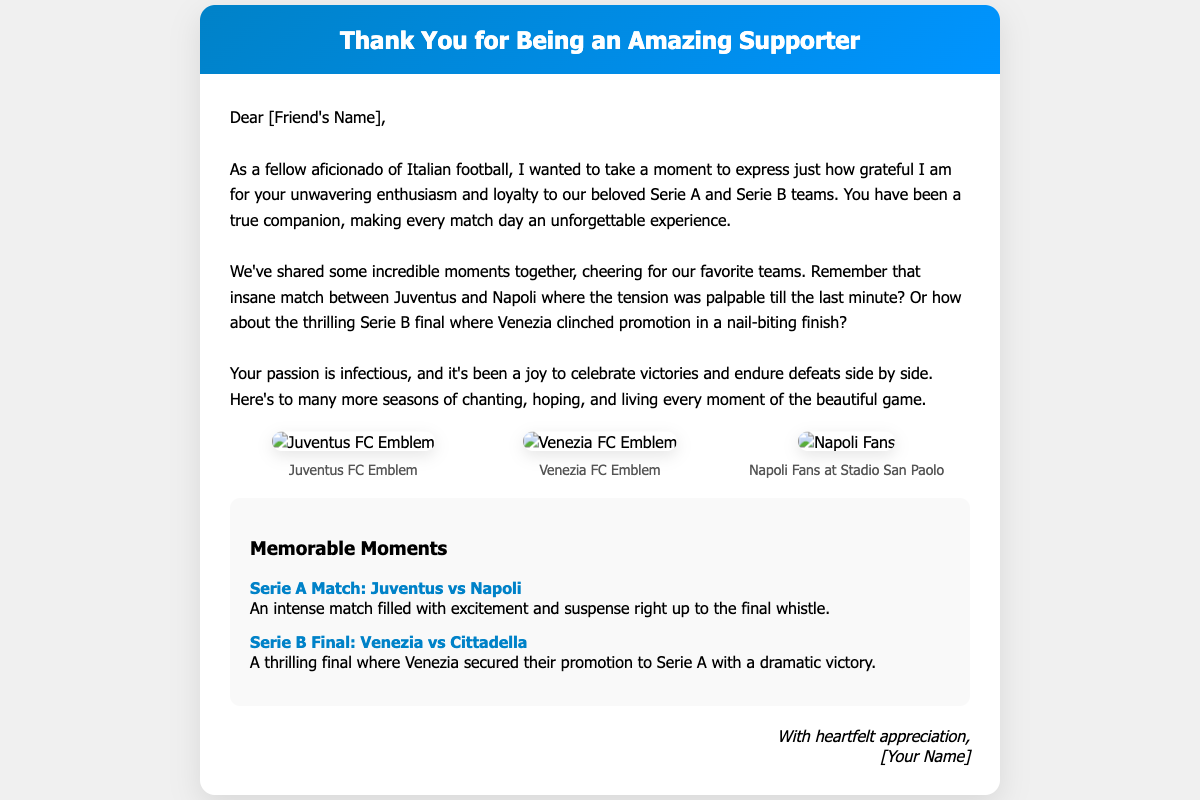What is the main purpose of the card? The main purpose of the card is to express gratitude towards a fellow fan for their support and enthusiasm.
Answer: To express gratitude Who is the card addressed to? The card is addressed to a friend, indicated by [Friend's Name].
Answer: [Friend's Name] What two teams are mentioned in the memorable moments? The two teams mentioned are Juventus and Venezia, as well as Napoli.
Answer: Juventus and Venezia How many images are included in the card? There are three images included in the card, showcasing team emblems and fan moments.
Answer: Three What significant event involving Venezia is highlighted? The significant event highlighted is Venezia securing promotion after a thrilling final match.
Answer: Promotion to Serie A What is the tone of the message in the card? The tone of the message in the card is one of appreciation and affection for shared experiences.
Answer: Appreciation What is the color theme of the card header? The card header features a gradient color theme, specifically blue tones.
Answer: Blue gradient What is included in the card under "Memorable Moments"? The card includes brief descriptions of memorable football matches reflecting key events experienced together.
Answer: Descriptions of matches Who is the sender of the card? The sender is indicated by [Your Name], who expresses heartfelt appreciation at the end.
Answer: [Your Name] 